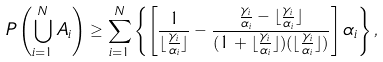Convert formula to latex. <formula><loc_0><loc_0><loc_500><loc_500>P \left ( \bigcup _ { i = 1 } ^ { N } A _ { i } \right ) \geq \sum _ { i = 1 } ^ { N } \left \{ \left [ \frac { 1 } { \lfloor \frac { \gamma _ { i } } { \alpha _ { i } } \rfloor } - \frac { \frac { \gamma _ { i } } { \alpha _ { i } } - \lfloor \frac { \gamma _ { i } } { \alpha _ { i } } \rfloor } { ( 1 + \lfloor \frac { \gamma _ { i } } { \alpha _ { i } } \rfloor ) ( \lfloor \frac { \gamma _ { i } } { \alpha _ { i } } \rfloor ) } \right ] \alpha _ { i } \right \} ,</formula> 